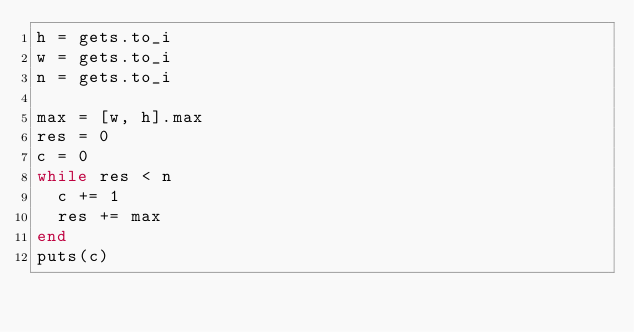Convert code to text. <code><loc_0><loc_0><loc_500><loc_500><_Ruby_>h = gets.to_i
w = gets.to_i
n = gets.to_i

max = [w, h].max
res = 0
c = 0
while res < n
  c += 1
  res += max
end
puts(c)
</code> 